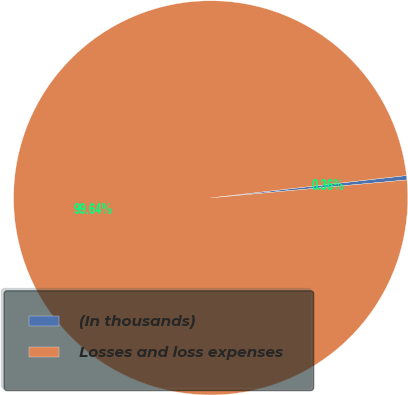<chart> <loc_0><loc_0><loc_500><loc_500><pie_chart><fcel>(In thousands)<fcel>Losses and loss expenses<nl><fcel>0.36%<fcel>99.64%<nl></chart> 